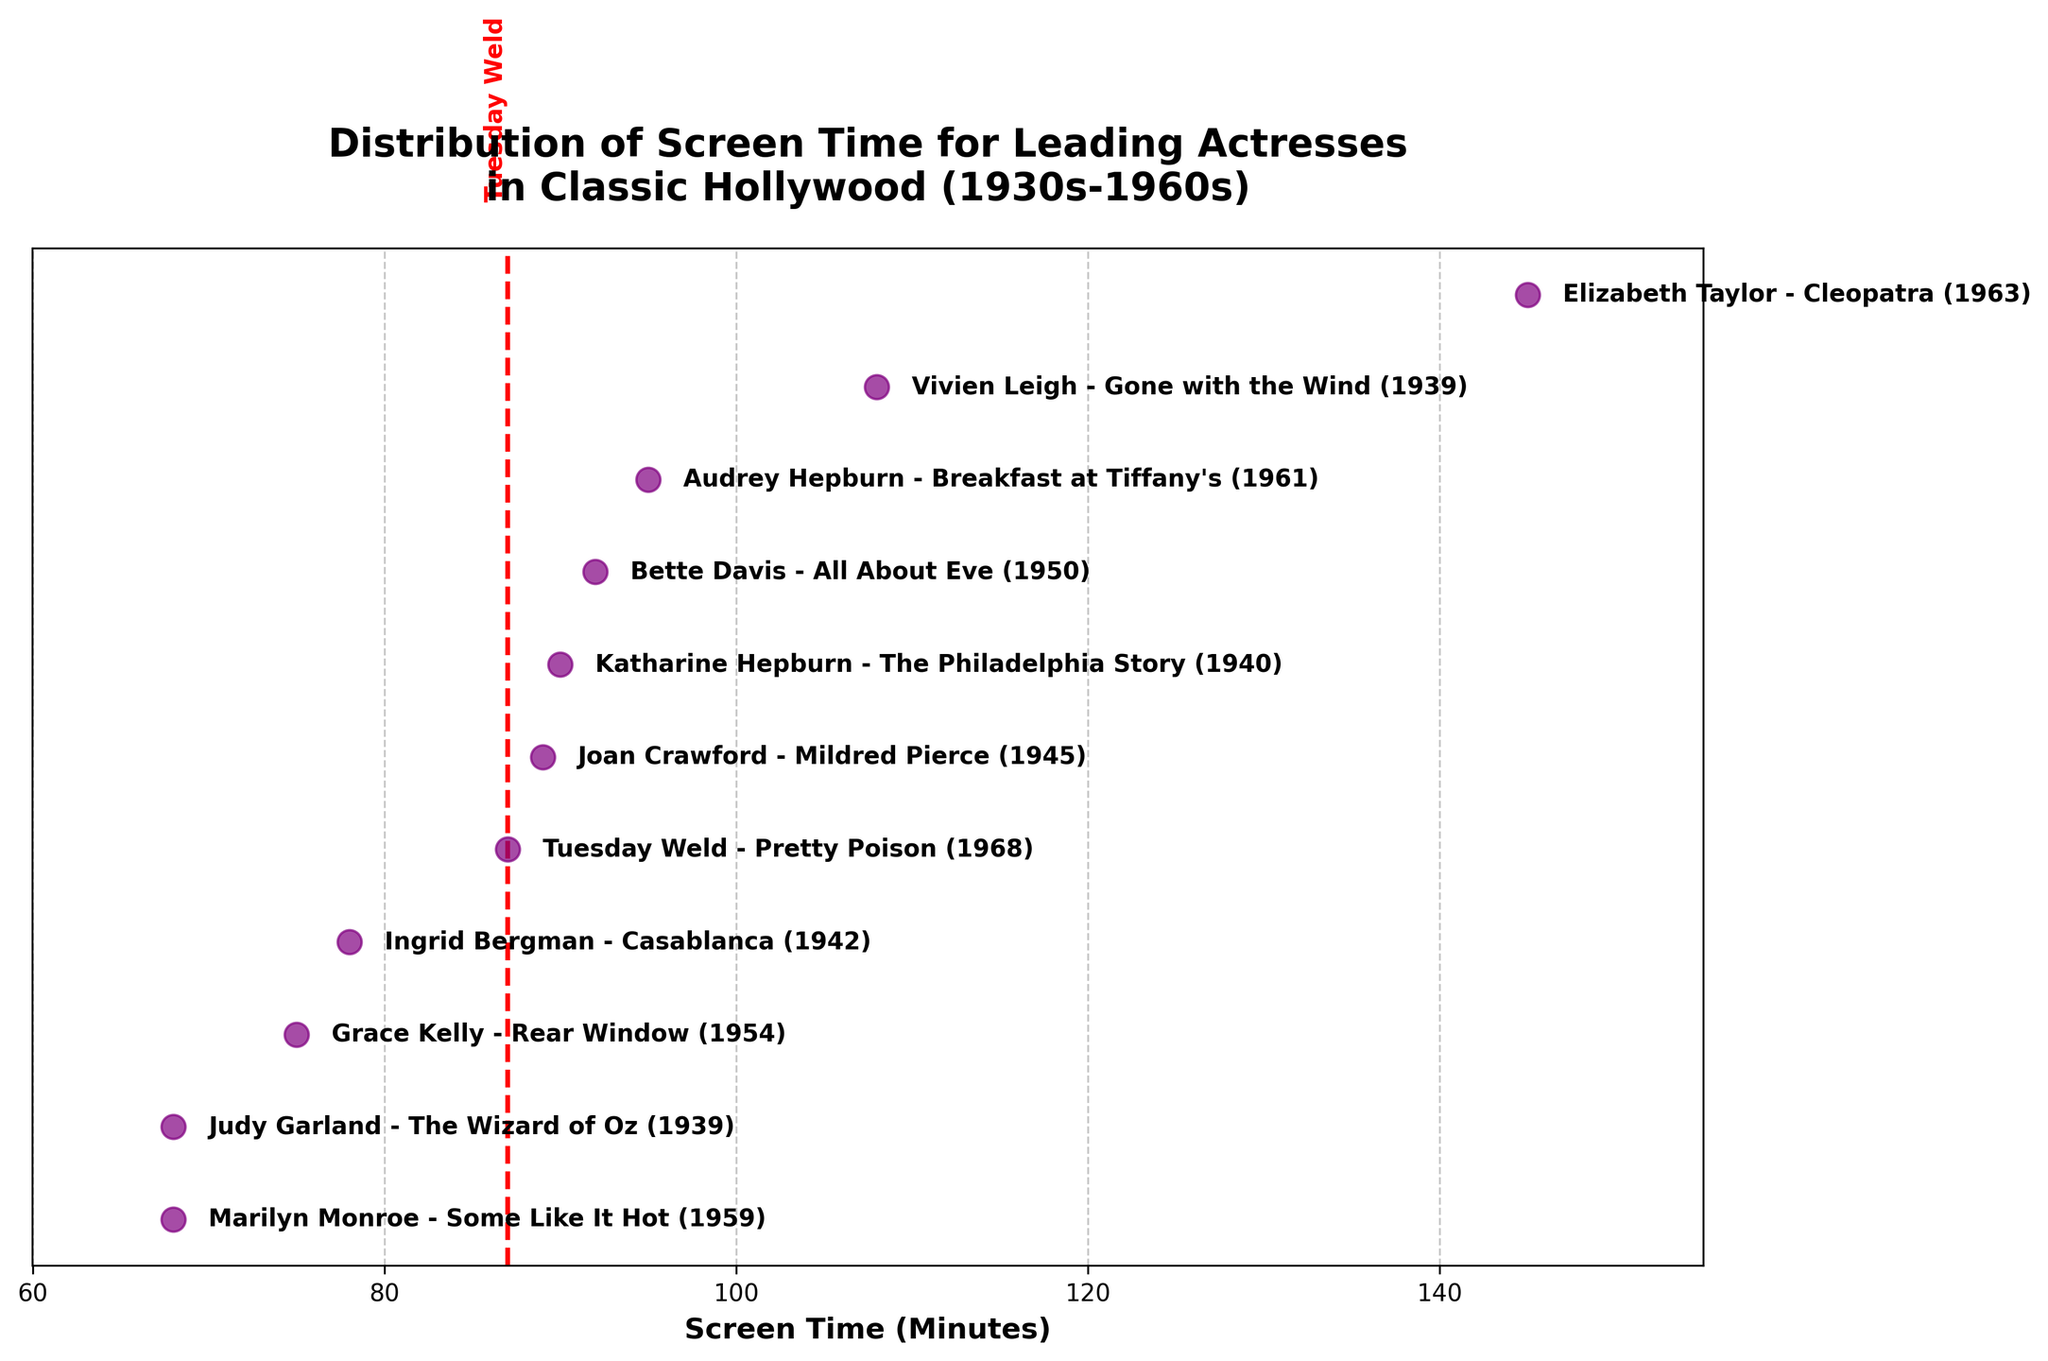What is the title of the plot? The title of the plot is located at the top center of the figure. It reads "Distribution of Screen Time for Leading Actresses in Classic Hollywood (1930s-1960s)".
Answer: Distribution of Screen Time for Leading Actresses in Classic Hollywood (1930s-1960s) How many actresses are represented in the plot? By counting the number of dots or text labels corresponding to actresses, we can see there are 11 actresses represented.
Answer: 11 Which actress has the maximum screen time and how much is it? The figure shows a dot furthest to the right for Elizabeth Taylor in "Cleopatra" (1963) with 145 minutes of screen time.
Answer: Elizabeth Taylor, 145 minutes What is the screen time for Tuesday Weld? The figure highlights Tuesday Weld's screen time with a vertical red dashed line at 87 minutes.
Answer: 87 minutes Who has more screen time: Audrey Hepburn in "Breakfast at Tiffany's" or Katharine Hepburn in "The Philadelphia Story"? By comparing their dots on the figure, Audrey Hepburn has 95 minutes, and Katharine Hepburn has 90 minutes. Thus, Audrey Hepburn has more screen time.
Answer: Audrey Hepburn What is the average screen time of the actresses in the plot? Adding up all screen times (92 + 108 + 78 + 95 + 90 + 68 + 145 + 75 + 89 + 68 + 87) and dividing by the number of actresses (11) gives the average: (995 / 11) ≈ 90.45 minutes.
Answer: 90.45 minutes Which film from the 1930s had the longest screen time and how long was it? The two films from the 1930s in the plot are "Gone with the Wind" (108 minutes) and "The Wizard of Oz" (68 minutes). "Gone with the Wind" has the longest screen time of the two.
Answer: Gone with the Wind, 108 minutes Relative to the average, how does the screen time of Marilyn Monroe in "Some Like It Hot" compare? The average screen time is approximately 90.45 minutes. Marilyn Monroe's screen time is 68 minutes, which is below the average.
Answer: Below the average Which actresses have screen times within a range of 5 minutes of Tuesday Weld's screen time? Tuesday Weld's screen time is 87 minutes. Actresses within 5 minutes range are Katharine Hepburn (90 minutes) and Joan Crawford (89 minutes).
Answer: Katharine Hepburn, Joan Crawford How does the screen time of Grace Kelly in "Rear Window" compare to that of Ingrid Bergman in "Casablanca"? Grace Kelly's screen time in "Rear Window" is 75 minutes, whereas Ingrid Bergman's screen time in "Casablanca" is 78 minutes. Thus, Ingrid Bergman has 3 minutes more screen time.
Answer: Ingrid Bergman has longer screen time 